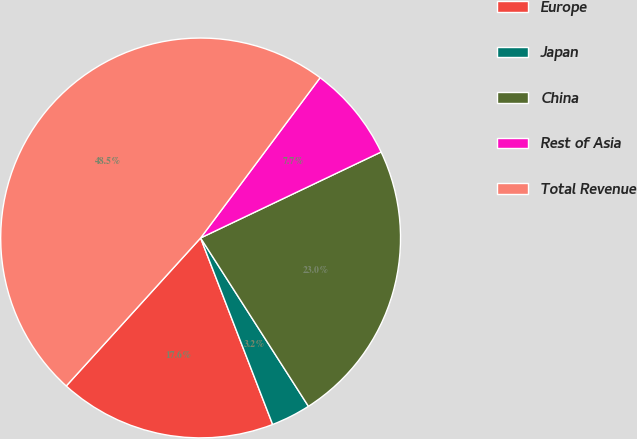Convert chart. <chart><loc_0><loc_0><loc_500><loc_500><pie_chart><fcel>Europe<fcel>Japan<fcel>China<fcel>Rest of Asia<fcel>Total Revenue<nl><fcel>17.6%<fcel>3.2%<fcel>23.01%<fcel>7.73%<fcel>48.47%<nl></chart> 